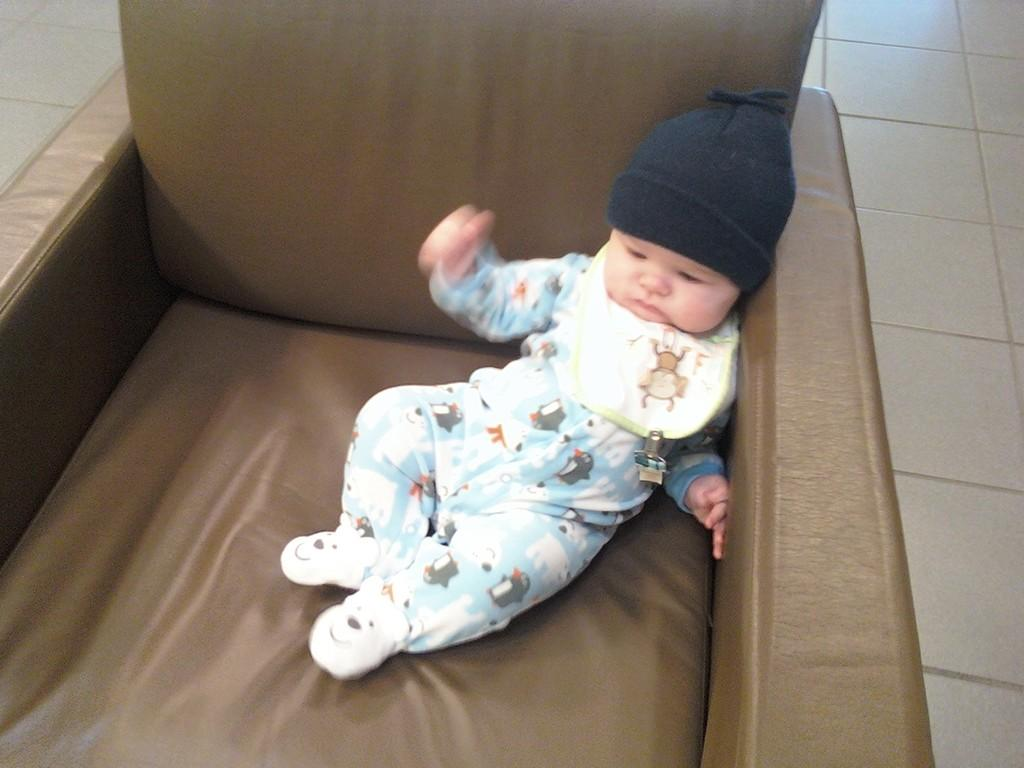What is the main subject of the image? There is a baby in the image. Where is the baby located? The baby is sitting on a couch. What can be seen in the background of the image? There is a floor visible in the background of the image. What type of request is the baby making in the image? There is no indication in the image that the baby is making any request. 